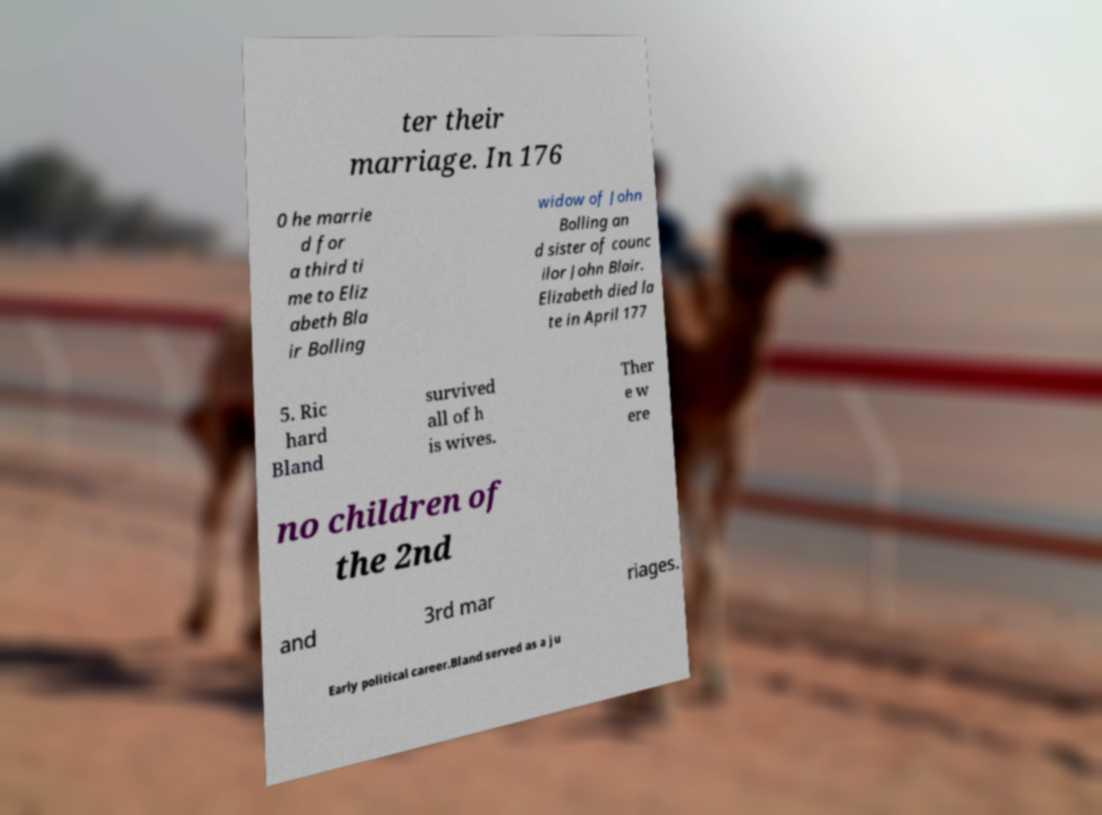Could you assist in decoding the text presented in this image and type it out clearly? ter their marriage. In 176 0 he marrie d for a third ti me to Eliz abeth Bla ir Bolling widow of John Bolling an d sister of counc ilor John Blair. Elizabeth died la te in April 177 5. Ric hard Bland survived all of h is wives. Ther e w ere no children of the 2nd and 3rd mar riages. Early political career.Bland served as a ju 